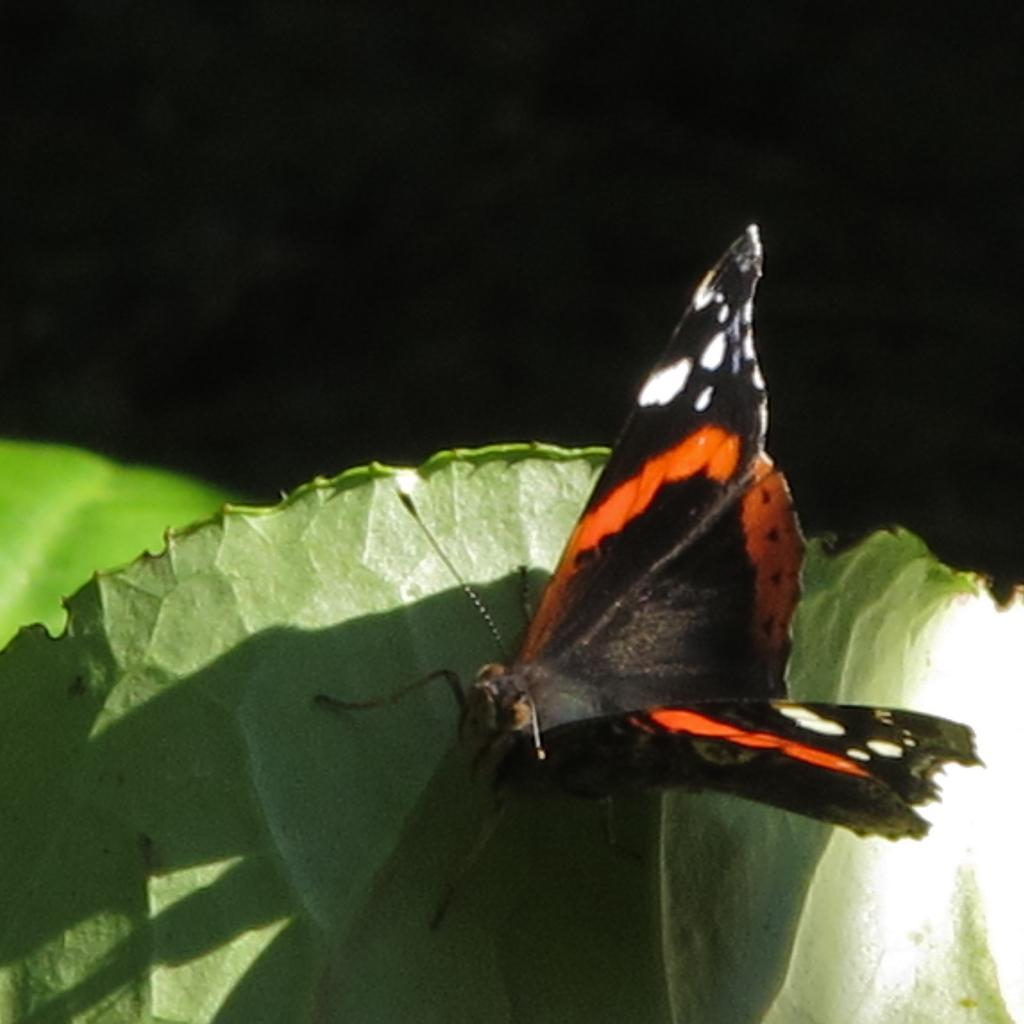How many leaves are visible in the image? There are two leaves in the image. What is present on one of the leaves? There is a butterfly on one of the leaves. What can be observed about the lighting in the image? The image is dark at the top. What color is the son's tongue in the image? There is no son or tongue present in the image; it features two leaves and a butterfly. 